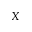<formula> <loc_0><loc_0><loc_500><loc_500>X</formula> 